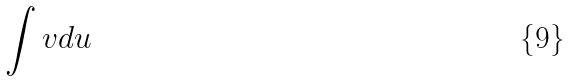<formula> <loc_0><loc_0><loc_500><loc_500>\int v d u</formula> 